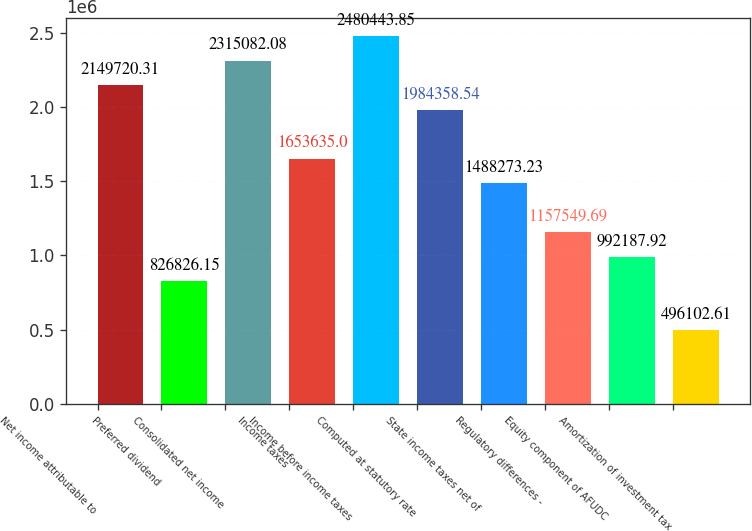Convert chart. <chart><loc_0><loc_0><loc_500><loc_500><bar_chart><fcel>Net income attributable to<fcel>Preferred dividend<fcel>Consolidated net income<fcel>Income taxes<fcel>Income before income taxes<fcel>Computed at statutory rate<fcel>State income taxes net of<fcel>Regulatory differences -<fcel>Equity component of AFUDC<fcel>Amortization of investment tax<nl><fcel>2.14972e+06<fcel>826826<fcel>2.31508e+06<fcel>1.65364e+06<fcel>2.48044e+06<fcel>1.98436e+06<fcel>1.48827e+06<fcel>1.15755e+06<fcel>992188<fcel>496103<nl></chart> 